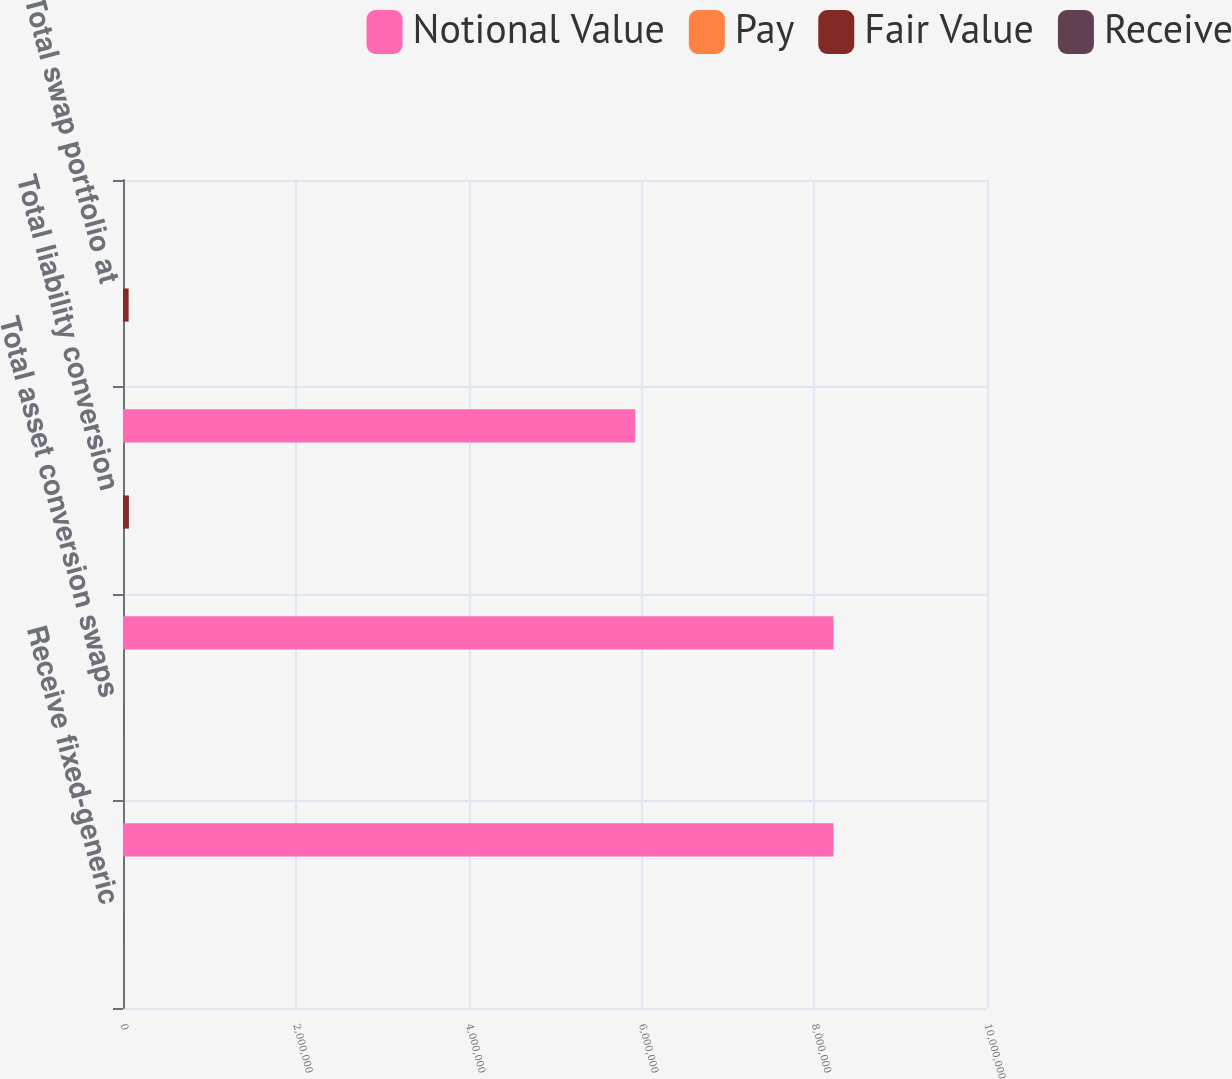<chart> <loc_0><loc_0><loc_500><loc_500><stacked_bar_chart><ecel><fcel>Receive fixed-generic<fcel>Total asset conversion swaps<fcel>Total liability conversion<fcel>Total swap portfolio at<nl><fcel>Notional Value<fcel>8.223e+06<fcel>8.223e+06<fcel>5.9291e+06<fcel>2.7<nl><fcel>Pay<fcel>1.1<fcel>1.1<fcel>2.7<fcel>1.8<nl><fcel>Fair Value<fcel>3103<fcel>3103<fcel>68401<fcel>65298<nl><fcel>Receive<fcel>0.83<fcel>0.83<fcel>1.55<fcel>1.13<nl></chart> 